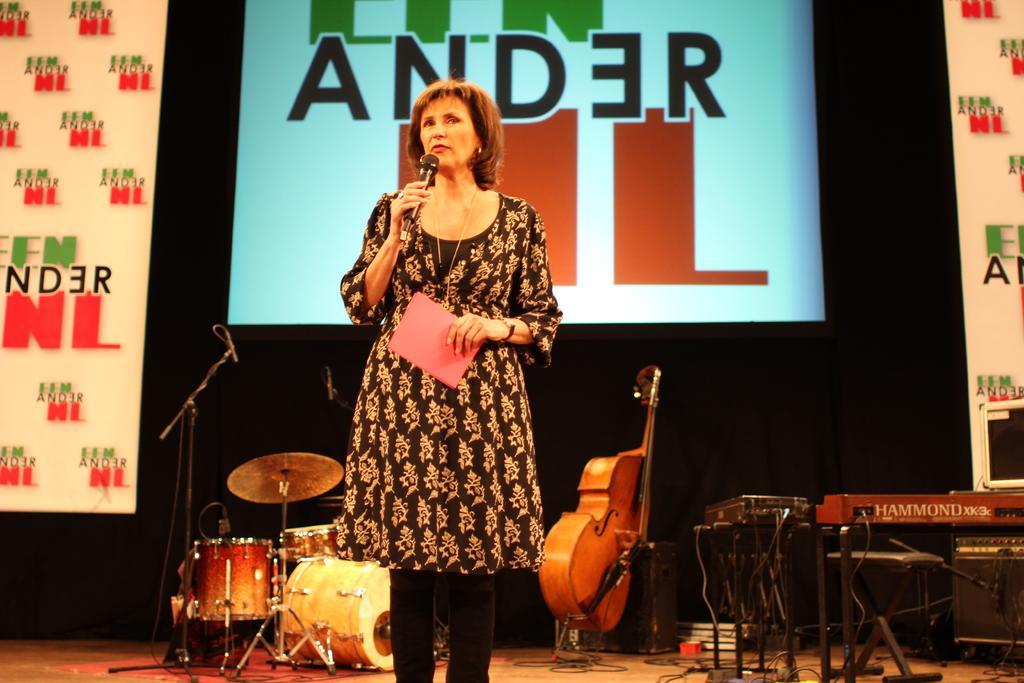Describe this image in one or two sentences. In this picture there is a woman standing on the dais, holding a card with her left hand and holding a microphone in her right hand. In the backdrop there is a drum set, a violin, piano and there is a screen. 